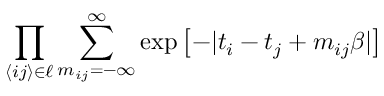<formula> <loc_0><loc_0><loc_500><loc_500>\prod _ { \langle i j \rangle \in \ell } \sum _ { m _ { i j } = - \infty } ^ { \infty } \exp \left [ - | t _ { i } - t _ { j } + m _ { i j } \beta | \right ]</formula> 